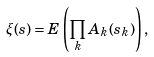Convert formula to latex. <formula><loc_0><loc_0><loc_500><loc_500>\xi ( s ) = E \left ( \prod _ { k } A _ { k } ( s _ { k } ) \right ) ,</formula> 